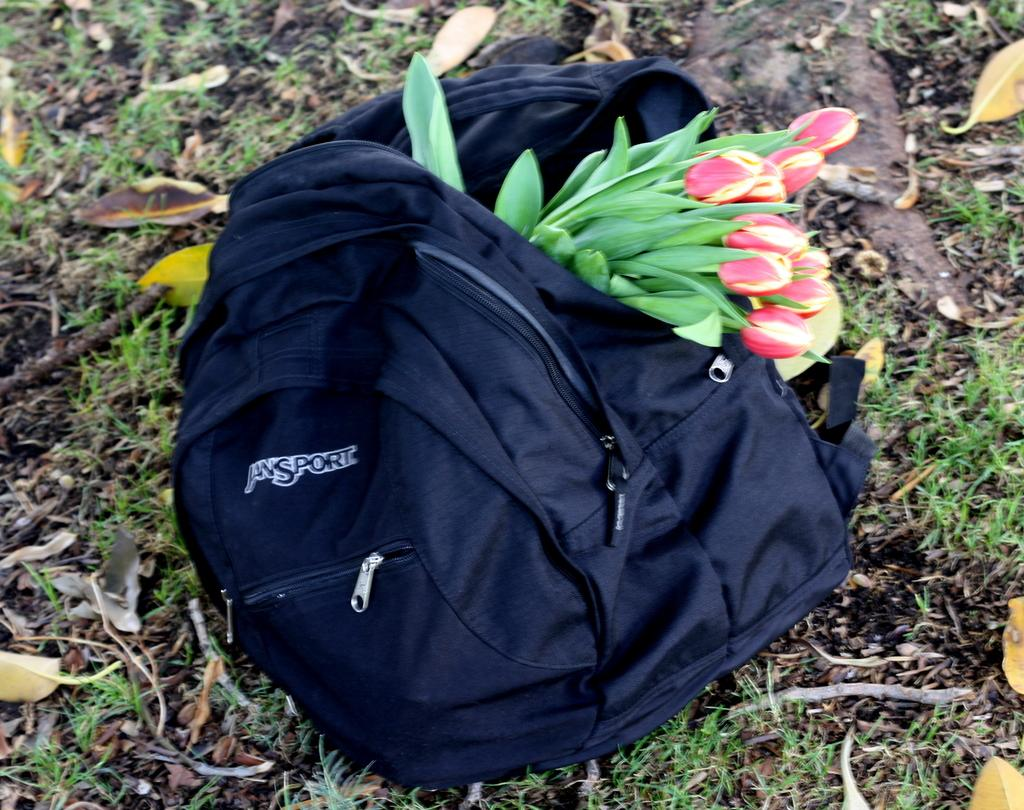What object is present on the ground in the image? There is a bag in the image. Can you describe the position of the bag in the image? The bag is placed on the ground. What is inside the bag that is visible in the image? The bag is full of flowers. What type of surface is the bag placed on? The ground is covered with grass. What type of bead is used to decorate the pan in the image? There is no pan or bead present in the image. What is the top of the bag made of in the image? The image does not provide information about the material of the bag's top. 